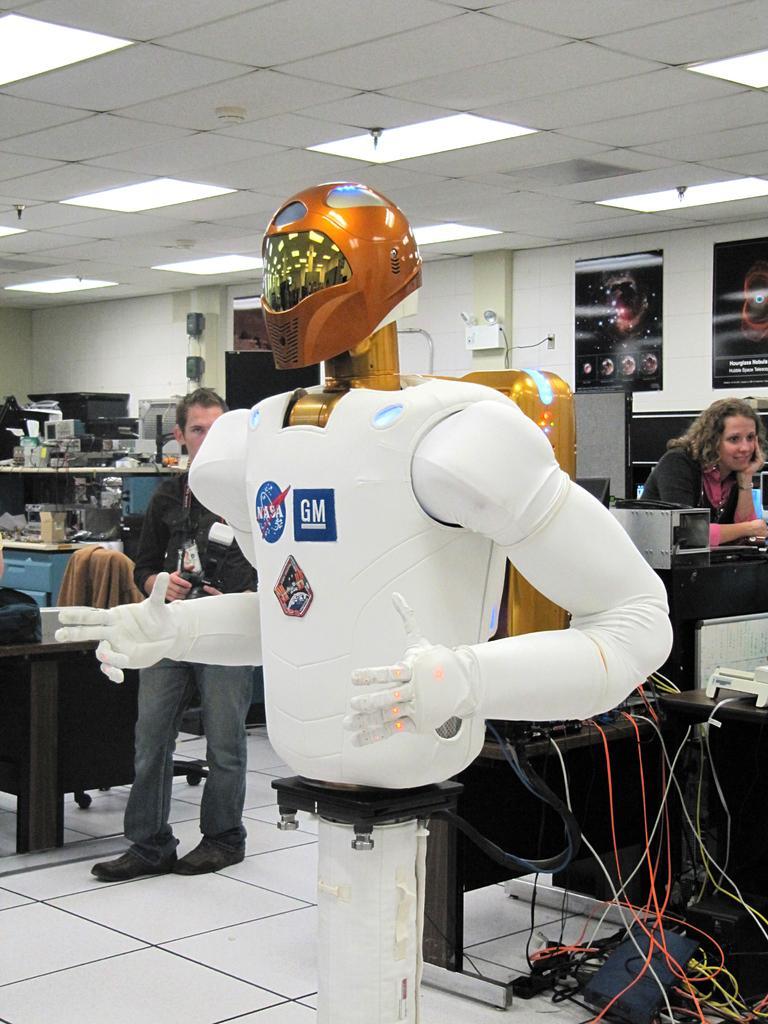Please provide a concise description of this image. In this image we can see a robot on a stand. We can also see wires, some people, devices and wires on the tables, frames on a wall and a roof with some ceiling lights. 